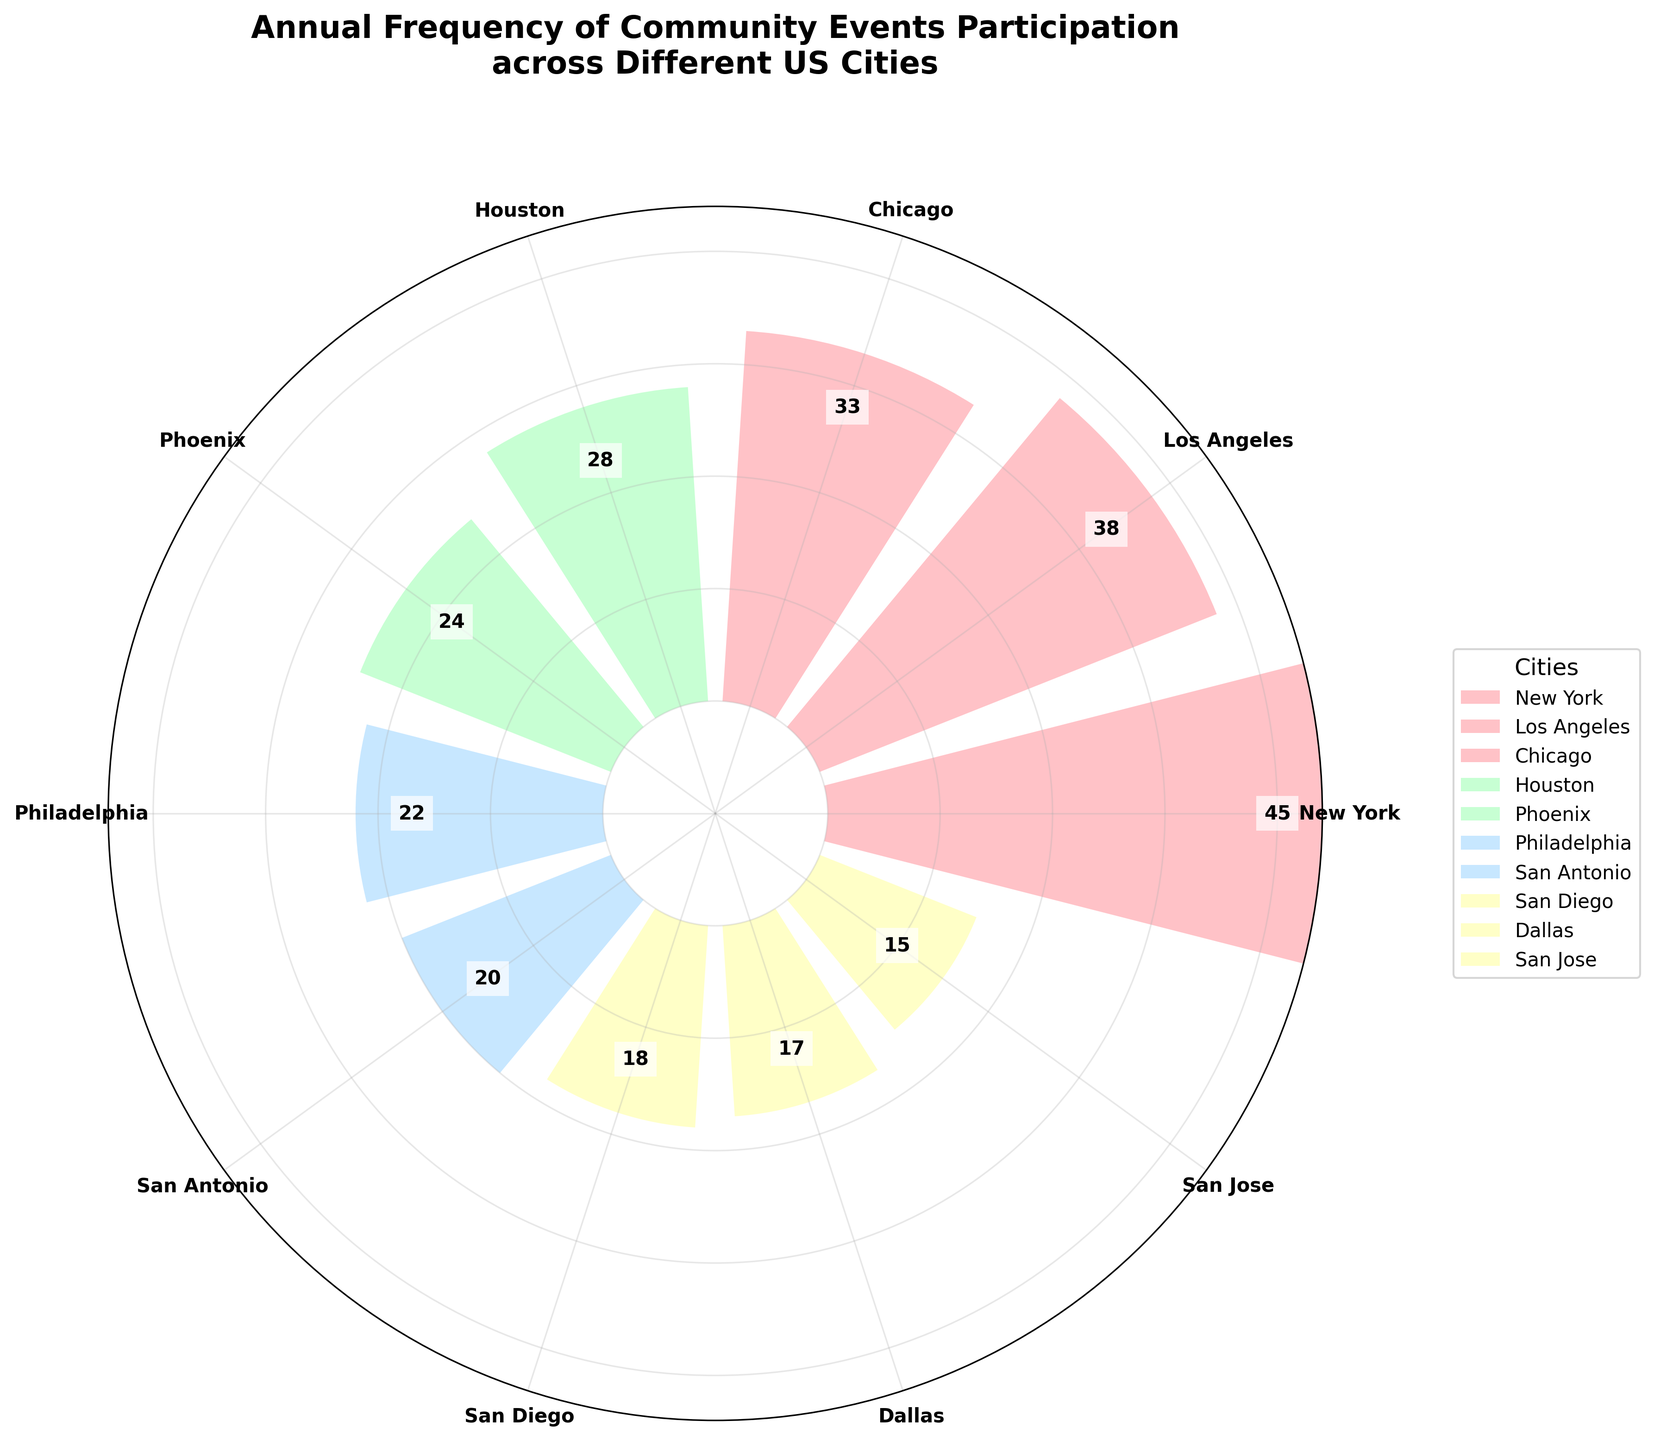What's the title of the figure? The title is found at the top of the figure. It describes what the plot represents.
Answer: Annual Frequency of Community Events Participation across Different US Cities How many cities are represented in the plot? Each city corresponds to a labeled tick on the outer rim of the rose chart. By counting the labels, one can determine the number of cities represented.
Answer: 10 Which city has the highest participation frequency? By comparing the lengths of the bars, the longest bar represents the highest participation frequency.
Answer: New York What's the participation frequency in Chicago? Look for the label "Chicago" on the chart and observe the numeric value inside the bar that corresponds to it.
Answer: 33 What is the difference in participation frequency between the cities with the highest and lowest frequencies? Identify the cities with the highest and lowest frequencies (New York with 45 and San Jose with 15), then subtract the lower value from the higher value.
Answer: 30 How does the participation frequency of Los Angeles compare to Houston? Identify the bars corresponding to Los Angeles and Houston, and compare their numeric values.
Answer: Los Angeles has 10 more than Houston Which city has the lowest participation frequency? By comparing the lengths of the bars, the shortest bar represents the lowest participation frequency.
Answer: San Jose What is the median participation frequency among the cities? List the frequencies in numerical order: [15, 17, 18, 20, 22, 24, 28, 33, 38, 45]. The median is the middle value in this ordered list.
Answer: 23 What color is the bar for Phoenix? Look for the label "Phoenix" on the chart and observe the color used for its corresponding bar.
Answer: A light blue shade Based on the plot, do more cities have a participation frequency above or below 25? Count the number of cities with frequencies > 25 and <= 25. [45, 38, 33, 28] are above 25 (4 cities), and [24, 22, 20, 18, 17, 15] are below 25 (6 cities).
Answer: Below 25 